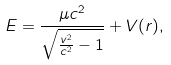<formula> <loc_0><loc_0><loc_500><loc_500>E = \frac { \mu c ^ { 2 } } { \sqrt { \frac { v ^ { 2 } } { c ^ { 2 } } - 1 } } + V ( r ) ,</formula> 